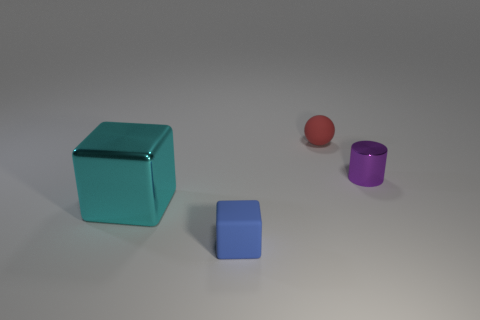What is the size of the thing that is both on the right side of the big cyan metallic thing and in front of the small purple shiny object?
Provide a succinct answer. Small. What color is the matte block?
Your answer should be compact. Blue. How many metallic cylinders are there?
Your answer should be very brief. 1. What number of tiny shiny things have the same color as the tiny metallic cylinder?
Offer a very short reply. 0. Do the tiny rubber object behind the small blue rubber cube and the thing that is right of the red thing have the same shape?
Your answer should be very brief. No. There is a shiny thing that is to the left of the small matte thing that is behind the small matte object that is in front of the cyan metallic object; what is its color?
Provide a succinct answer. Cyan. What is the color of the small object that is on the right side of the small red rubber object?
Provide a short and direct response. Purple. There is a shiny object that is the same size as the blue cube; what color is it?
Your answer should be compact. Purple. Is the cyan cube the same size as the rubber ball?
Provide a succinct answer. No. How many blue blocks are on the left side of the big thing?
Your response must be concise. 0. 